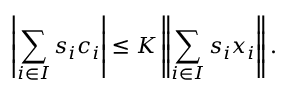<formula> <loc_0><loc_0><loc_500><loc_500>\left | \sum _ { i \in I } s _ { i } c _ { i } \right | \leq K \left \| \sum _ { i \in I } s _ { i } x _ { i } \right \| .</formula> 